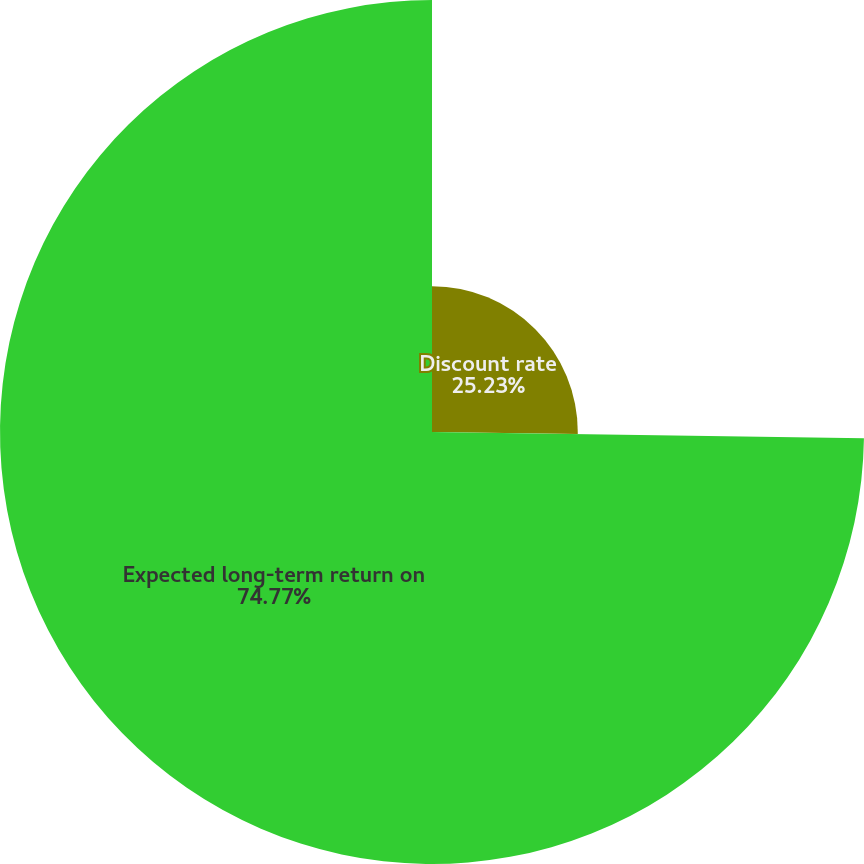Convert chart. <chart><loc_0><loc_0><loc_500><loc_500><pie_chart><fcel>Discount rate<fcel>Expected long-term return on<nl><fcel>25.23%<fcel>74.77%<nl></chart> 